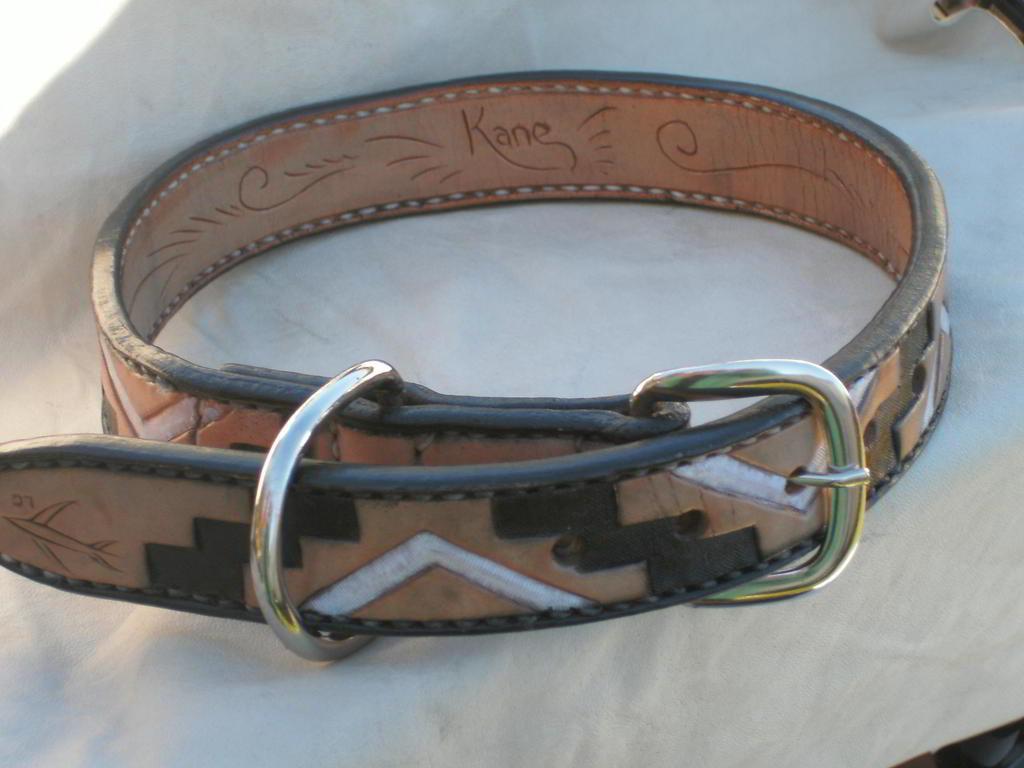Could you give a brief overview of what you see in this image? There is a belt placed on a white surface,there is some brown and white color design made on the belt. 